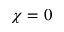<formula> <loc_0><loc_0><loc_500><loc_500>\chi = 0</formula> 